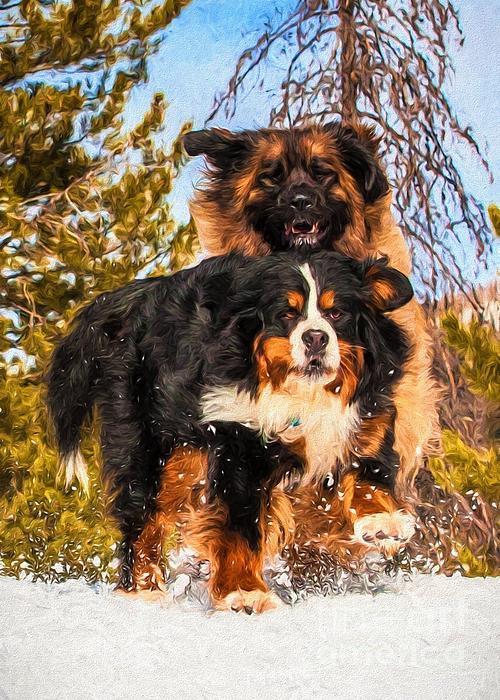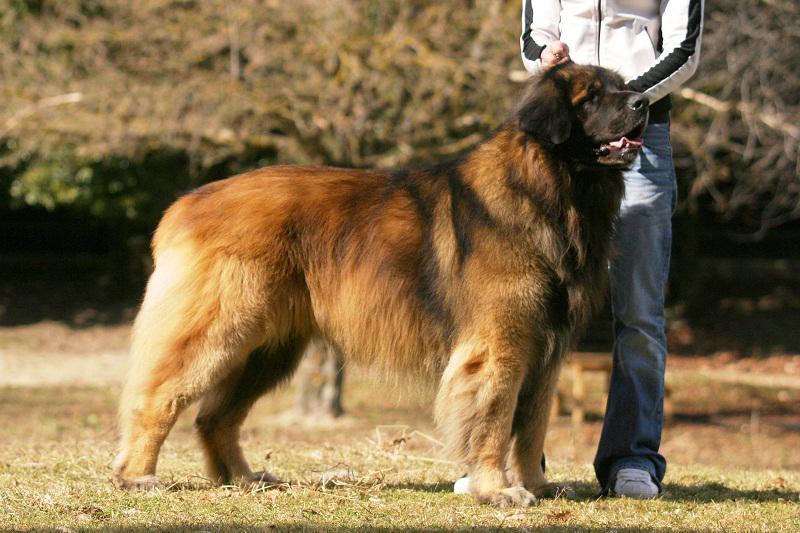The first image is the image on the left, the second image is the image on the right. Considering the images on both sides, is "Two dogs wearing something around their necks are posed side-by-side outdoors in front of yellow foliage." valid? Answer yes or no. No. 